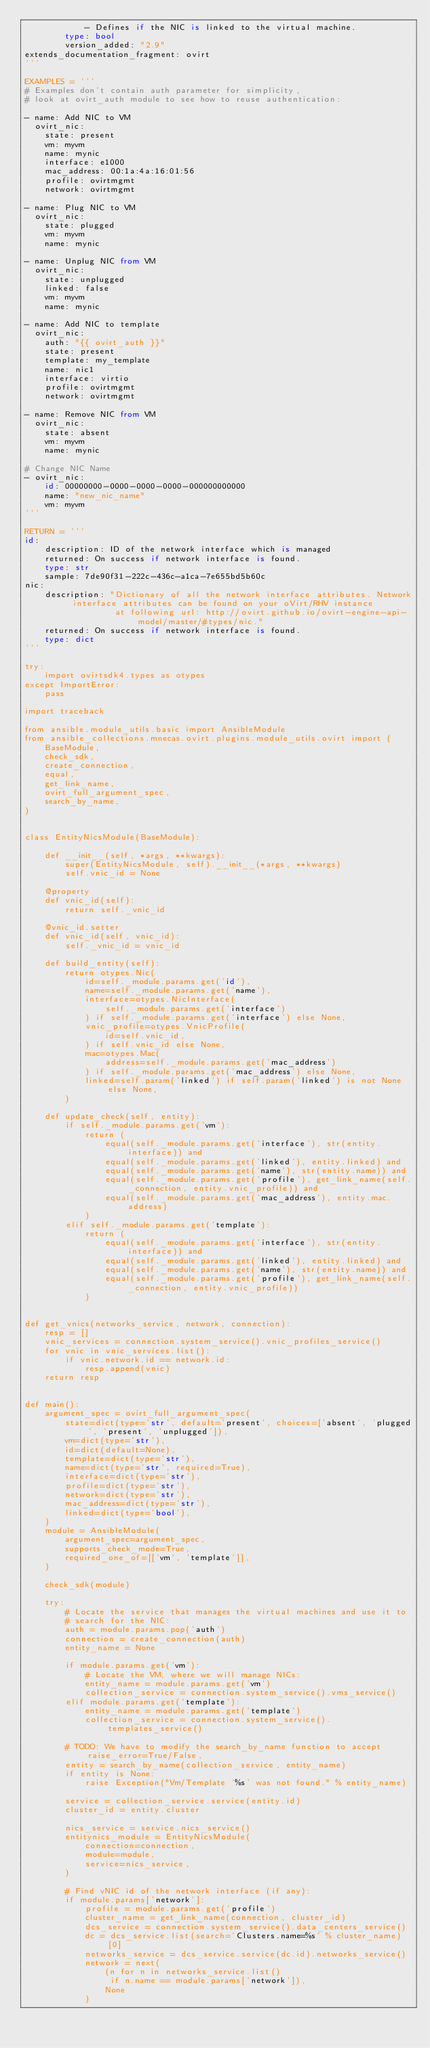Convert code to text. <code><loc_0><loc_0><loc_500><loc_500><_Python_>            - Defines if the NIC is linked to the virtual machine.
        type: bool
        version_added: "2.9"
extends_documentation_fragment: ovirt
'''

EXAMPLES = '''
# Examples don't contain auth parameter for simplicity,
# look at ovirt_auth module to see how to reuse authentication:

- name: Add NIC to VM
  ovirt_nic:
    state: present
    vm: myvm
    name: mynic
    interface: e1000
    mac_address: 00:1a:4a:16:01:56
    profile: ovirtmgmt
    network: ovirtmgmt

- name: Plug NIC to VM
  ovirt_nic:
    state: plugged
    vm: myvm
    name: mynic

- name: Unplug NIC from VM
  ovirt_nic:
    state: unplugged
    linked: false
    vm: myvm
    name: mynic

- name: Add NIC to template
  ovirt_nic:
    auth: "{{ ovirt_auth }}"
    state: present
    template: my_template
    name: nic1
    interface: virtio
    profile: ovirtmgmt
    network: ovirtmgmt

- name: Remove NIC from VM
  ovirt_nic:
    state: absent
    vm: myvm
    name: mynic

# Change NIC Name
- ovirt_nic:
    id: 00000000-0000-0000-0000-000000000000
    name: "new_nic_name"
    vm: myvm
'''

RETURN = '''
id:
    description: ID of the network interface which is managed
    returned: On success if network interface is found.
    type: str
    sample: 7de90f31-222c-436c-a1ca-7e655bd5b60c
nic:
    description: "Dictionary of all the network interface attributes. Network interface attributes can be found on your oVirt/RHV instance
                  at following url: http://ovirt.github.io/ovirt-engine-api-model/master/#types/nic."
    returned: On success if network interface is found.
    type: dict
'''

try:
    import ovirtsdk4.types as otypes
except ImportError:
    pass

import traceback

from ansible.module_utils.basic import AnsibleModule
from ansible_collections.mnecas.ovirt.plugins.module_utils.ovirt import (
    BaseModule,
    check_sdk,
    create_connection,
    equal,
    get_link_name,
    ovirt_full_argument_spec,
    search_by_name,
)


class EntityNicsModule(BaseModule):

    def __init__(self, *args, **kwargs):
        super(EntityNicsModule, self).__init__(*args, **kwargs)
        self.vnic_id = None

    @property
    def vnic_id(self):
        return self._vnic_id

    @vnic_id.setter
    def vnic_id(self, vnic_id):
        self._vnic_id = vnic_id

    def build_entity(self):
        return otypes.Nic(
            id=self._module.params.get('id'),
            name=self._module.params.get('name'),
            interface=otypes.NicInterface(
                self._module.params.get('interface')
            ) if self._module.params.get('interface') else None,
            vnic_profile=otypes.VnicProfile(
                id=self.vnic_id,
            ) if self.vnic_id else None,
            mac=otypes.Mac(
                address=self._module.params.get('mac_address')
            ) if self._module.params.get('mac_address') else None,
            linked=self.param('linked') if self.param('linked') is not None else None,
        )

    def update_check(self, entity):
        if self._module.params.get('vm'):
            return (
                equal(self._module.params.get('interface'), str(entity.interface)) and
                equal(self._module.params.get('linked'), entity.linked) and
                equal(self._module.params.get('name'), str(entity.name)) and
                equal(self._module.params.get('profile'), get_link_name(self._connection, entity.vnic_profile)) and
                equal(self._module.params.get('mac_address'), entity.mac.address)
            )
        elif self._module.params.get('template'):
            return (
                equal(self._module.params.get('interface'), str(entity.interface)) and
                equal(self._module.params.get('linked'), entity.linked) and
                equal(self._module.params.get('name'), str(entity.name)) and
                equal(self._module.params.get('profile'), get_link_name(self._connection, entity.vnic_profile))
            )


def get_vnics(networks_service, network, connection):
    resp = []
    vnic_services = connection.system_service().vnic_profiles_service()
    for vnic in vnic_services.list():
        if vnic.network.id == network.id:
            resp.append(vnic)
    return resp


def main():
    argument_spec = ovirt_full_argument_spec(
        state=dict(type='str', default='present', choices=['absent', 'plugged', 'present', 'unplugged']),
        vm=dict(type='str'),
        id=dict(default=None),
        template=dict(type='str'),
        name=dict(type='str', required=True),
        interface=dict(type='str'),
        profile=dict(type='str'),
        network=dict(type='str'),
        mac_address=dict(type='str'),
        linked=dict(type='bool'),
    )
    module = AnsibleModule(
        argument_spec=argument_spec,
        supports_check_mode=True,
        required_one_of=[['vm', 'template']],
    )

    check_sdk(module)

    try:
        # Locate the service that manages the virtual machines and use it to
        # search for the NIC:
        auth = module.params.pop('auth')
        connection = create_connection(auth)
        entity_name = None

        if module.params.get('vm'):
            # Locate the VM, where we will manage NICs:
            entity_name = module.params.get('vm')
            collection_service = connection.system_service().vms_service()
        elif module.params.get('template'):
            entity_name = module.params.get('template')
            collection_service = connection.system_service().templates_service()

        # TODO: We have to modify the search_by_name function to accept raise_error=True/False,
        entity = search_by_name(collection_service, entity_name)
        if entity is None:
            raise Exception("Vm/Template '%s' was not found." % entity_name)

        service = collection_service.service(entity.id)
        cluster_id = entity.cluster

        nics_service = service.nics_service()
        entitynics_module = EntityNicsModule(
            connection=connection,
            module=module,
            service=nics_service,
        )

        # Find vNIC id of the network interface (if any):
        if module.params['network']:
            profile = module.params.get('profile')
            cluster_name = get_link_name(connection, cluster_id)
            dcs_service = connection.system_service().data_centers_service()
            dc = dcs_service.list(search='Clusters.name=%s' % cluster_name)[0]
            networks_service = dcs_service.service(dc.id).networks_service()
            network = next(
                (n for n in networks_service.list()
                 if n.name == module.params['network']),
                None
            )</code> 